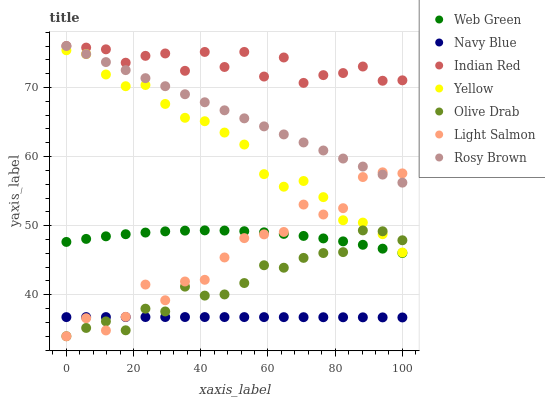Does Navy Blue have the minimum area under the curve?
Answer yes or no. Yes. Does Indian Red have the maximum area under the curve?
Answer yes or no. Yes. Does Rosy Brown have the minimum area under the curve?
Answer yes or no. No. Does Rosy Brown have the maximum area under the curve?
Answer yes or no. No. Is Rosy Brown the smoothest?
Answer yes or no. Yes. Is Indian Red the roughest?
Answer yes or no. Yes. Is Navy Blue the smoothest?
Answer yes or no. No. Is Navy Blue the roughest?
Answer yes or no. No. Does Light Salmon have the lowest value?
Answer yes or no. Yes. Does Navy Blue have the lowest value?
Answer yes or no. No. Does Indian Red have the highest value?
Answer yes or no. Yes. Does Navy Blue have the highest value?
Answer yes or no. No. Is Navy Blue less than Rosy Brown?
Answer yes or no. Yes. Is Web Green greater than Navy Blue?
Answer yes or no. Yes. Does Web Green intersect Light Salmon?
Answer yes or no. Yes. Is Web Green less than Light Salmon?
Answer yes or no. No. Is Web Green greater than Light Salmon?
Answer yes or no. No. Does Navy Blue intersect Rosy Brown?
Answer yes or no. No. 